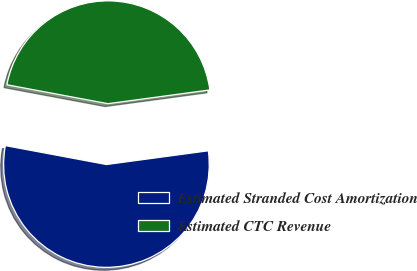Convert chart to OTSL. <chart><loc_0><loc_0><loc_500><loc_500><pie_chart><fcel>Estimated Stranded Cost Amortization<fcel>Estimated CTC Revenue<nl><fcel>55.08%<fcel>44.92%<nl></chart> 